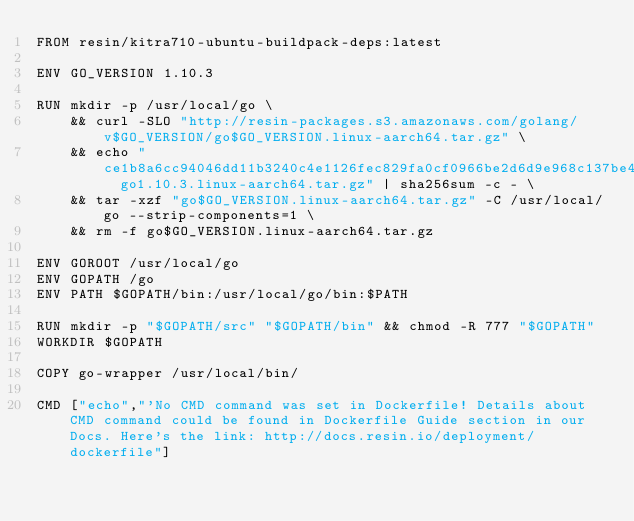<code> <loc_0><loc_0><loc_500><loc_500><_Dockerfile_>FROM resin/kitra710-ubuntu-buildpack-deps:latest

ENV GO_VERSION 1.10.3

RUN mkdir -p /usr/local/go \
	&& curl -SLO "http://resin-packages.s3.amazonaws.com/golang/v$GO_VERSION/go$GO_VERSION.linux-aarch64.tar.gz" \
	&& echo "ce1b8a6cc94046dd11b3240c4e1126fec829fa0cf0966be2d6d9e968c137be48  go1.10.3.linux-aarch64.tar.gz" | sha256sum -c - \
	&& tar -xzf "go$GO_VERSION.linux-aarch64.tar.gz" -C /usr/local/go --strip-components=1 \
	&& rm -f go$GO_VERSION.linux-aarch64.tar.gz

ENV GOROOT /usr/local/go
ENV GOPATH /go
ENV PATH $GOPATH/bin:/usr/local/go/bin:$PATH

RUN mkdir -p "$GOPATH/src" "$GOPATH/bin" && chmod -R 777 "$GOPATH"
WORKDIR $GOPATH

COPY go-wrapper /usr/local/bin/

CMD ["echo","'No CMD command was set in Dockerfile! Details about CMD command could be found in Dockerfile Guide section in our Docs. Here's the link: http://docs.resin.io/deployment/dockerfile"]
</code> 